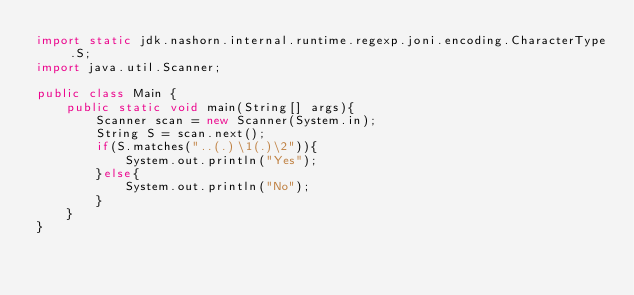<code> <loc_0><loc_0><loc_500><loc_500><_Java_>import static jdk.nashorn.internal.runtime.regexp.joni.encoding.CharacterType.S;
import java.util.Scanner;

public class Main {
    public static void main(String[] args){
        Scanner scan = new Scanner(System.in);
        String S = scan.next();
        if(S.matches("..(.)\1(.)\2")){
            System.out.println("Yes");
        }else{
            System.out.println("No");
        }
    }
}
</code> 